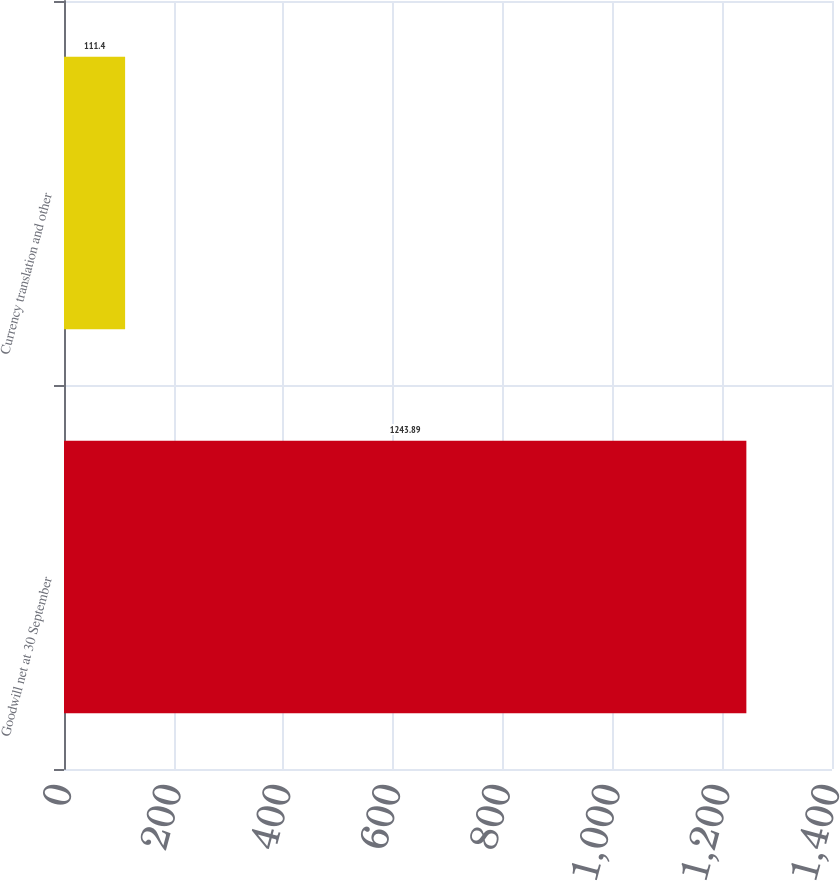<chart> <loc_0><loc_0><loc_500><loc_500><bar_chart><fcel>Goodwill net at 30 September<fcel>Currency translation and other<nl><fcel>1243.89<fcel>111.4<nl></chart> 